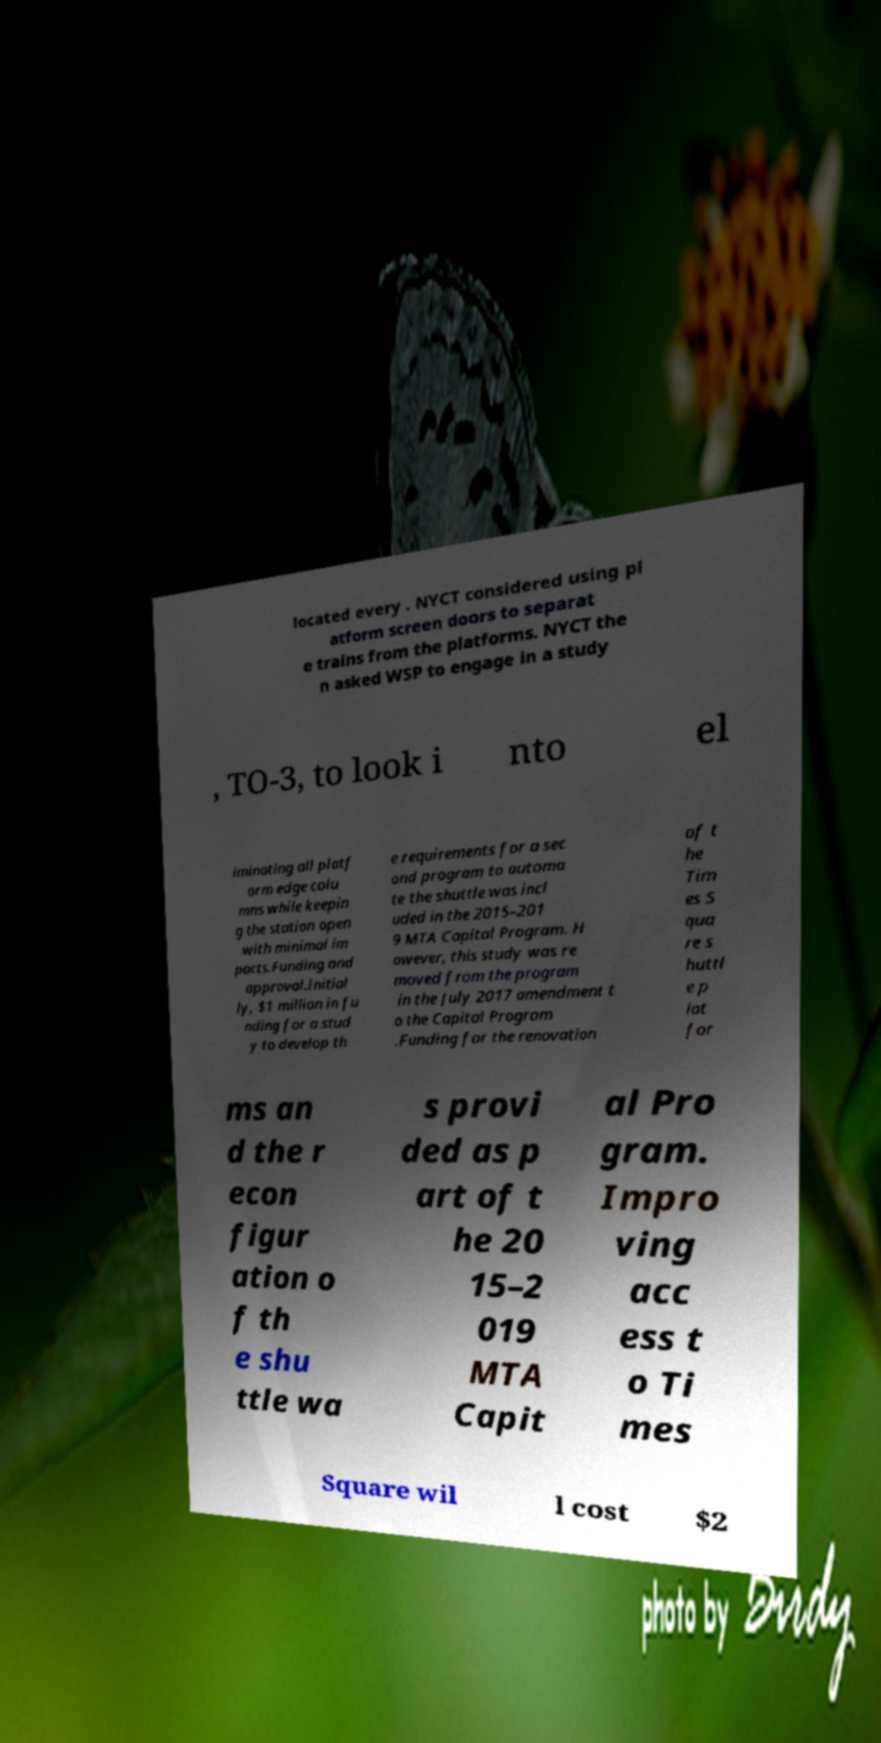Can you read and provide the text displayed in the image?This photo seems to have some interesting text. Can you extract and type it out for me? located every . NYCT considered using pl atform screen doors to separat e trains from the platforms. NYCT the n asked WSP to engage in a study , TO-3, to look i nto el iminating all platf orm edge colu mns while keepin g the station open with minimal im pacts.Funding and approval.Initial ly, $1 million in fu nding for a stud y to develop th e requirements for a sec ond program to automa te the shuttle was incl uded in the 2015–201 9 MTA Capital Program. H owever, this study was re moved from the program in the July 2017 amendment t o the Capital Program .Funding for the renovation of t he Tim es S qua re s huttl e p lat for ms an d the r econ figur ation o f th e shu ttle wa s provi ded as p art of t he 20 15–2 019 MTA Capit al Pro gram. Impro ving acc ess t o Ti mes Square wil l cost $2 